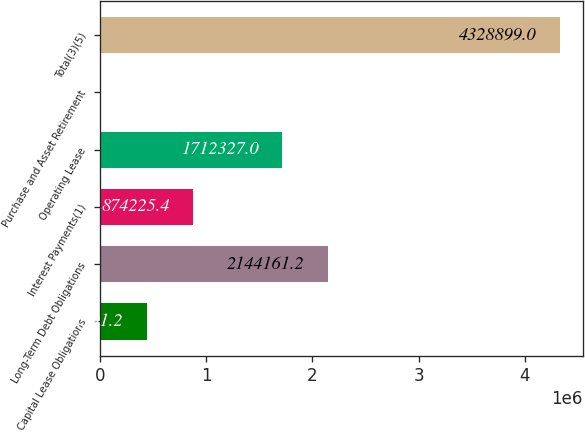Convert chart. <chart><loc_0><loc_0><loc_500><loc_500><bar_chart><fcel>Capital Lease Obligations<fcel>Long-Term Debt Obligations<fcel>Interest Payments(1)<fcel>Operating Lease<fcel>Purchase and Asset Retirement<fcel>Total(3)(5)<nl><fcel>442391<fcel>2.14416e+06<fcel>874225<fcel>1.71233e+06<fcel>10557<fcel>4.3289e+06<nl></chart> 